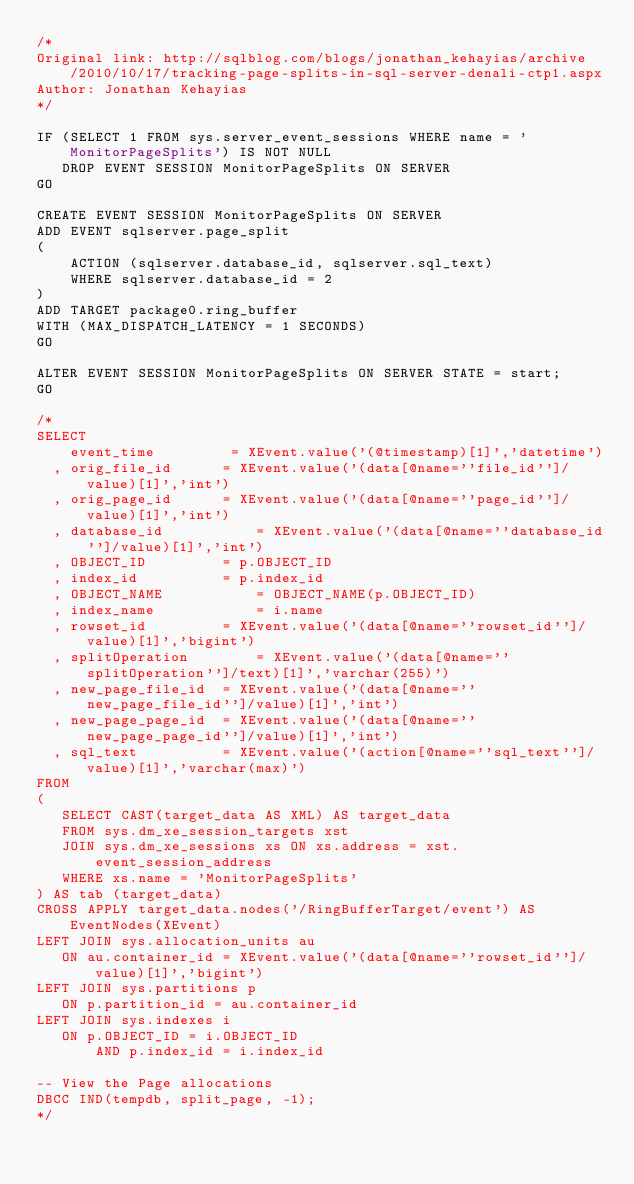<code> <loc_0><loc_0><loc_500><loc_500><_SQL_>/*
Original link: http://sqlblog.com/blogs/jonathan_kehayias/archive/2010/10/17/tracking-page-splits-in-sql-server-denali-ctp1.aspx
Author: Jonathan Kehayias
*/

IF (SELECT 1 FROM sys.server_event_sessions WHERE name = 'MonitorPageSplits') IS NOT NULL
   DROP EVENT SESSION MonitorPageSplits ON SERVER 
GO

CREATE EVENT SESSION MonitorPageSplits ON SERVER 
ADD EVENT sqlserver.page_split 
( 
    ACTION (sqlserver.database_id, sqlserver.sql_text)   
    WHERE sqlserver.database_id = 2 
) 
ADD TARGET package0.ring_buffer 
WITH (MAX_DISPATCH_LATENCY = 1 SECONDS)
GO

ALTER EVENT SESSION MonitorPageSplits ON SERVER STATE = start;
GO

/*
SELECT 
    event_time         = XEvent.value('(@timestamp)[1]','datetime') 
  , orig_file_id      = XEvent.value('(data[@name=''file_id'']/value)[1]','int') 
  , orig_page_id      = XEvent.value('(data[@name=''page_id'']/value)[1]','int') 
  , database_id           = XEvent.value('(data[@name=''database_id'']/value)[1]','int') 
  , OBJECT_ID         = p.OBJECT_ID
  , index_id          = p.index_id
  , OBJECT_NAME           = OBJECT_NAME(p.OBJECT_ID)
  , index_name            = i.name
  , rowset_id         = XEvent.value('(data[@name=''rowset_id'']/value)[1]','bigint') 
  , splitOperation        = XEvent.value('(data[@name=''splitOperation'']/text)[1]','varchar(255)') 
  , new_page_file_id  = XEvent.value('(data[@name=''new_page_file_id'']/value)[1]','int') 
  , new_page_page_id  = XEvent.value('(data[@name=''new_page_page_id'']/value)[1]','int') 
  , sql_text          = XEvent.value('(action[@name=''sql_text'']/value)[1]','varchar(max)') 
FROM 
( 
   SELECT CAST(target_data AS XML) AS target_data 
   FROM sys.dm_xe_session_targets xst 
   JOIN sys.dm_xe_sessions xs ON xs.address = xst.event_session_address 
   WHERE xs.name = 'MonitorPageSplits' 
) AS tab (target_data) 
CROSS APPLY target_data.nodes('/RingBufferTarget/event') AS EventNodes(XEvent) 
LEFT JOIN sys.allocation_units au
   ON au.container_id = XEvent.value('(data[@name=''rowset_id'']/value)[1]','bigint') 
LEFT JOIN sys.partitions p 
   ON p.partition_id = au.container_id  
LEFT JOIN sys.indexes i
   ON p.OBJECT_ID = i.OBJECT_ID
       AND p.index_id = i.index_id

-- View the Page allocations 
DBCC IND(tempdb, split_page, -1);
*/
</code> 